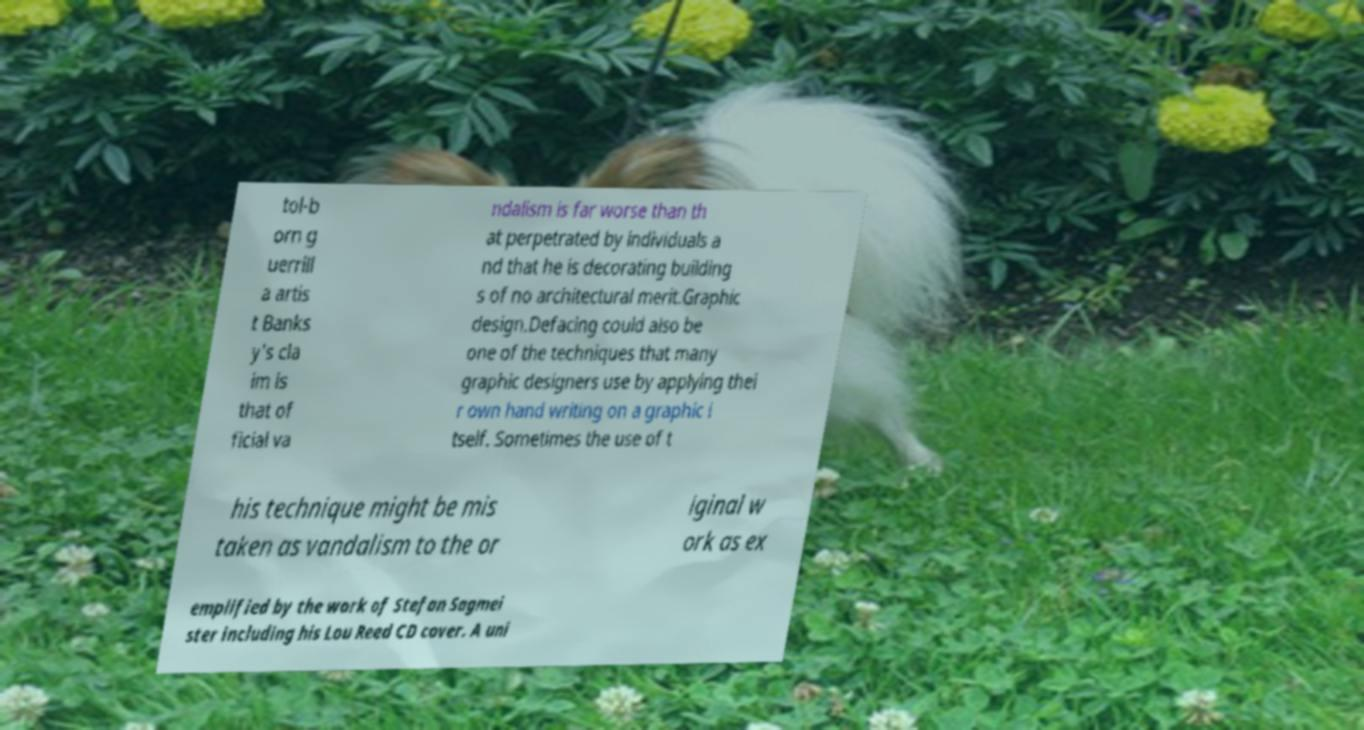I need the written content from this picture converted into text. Can you do that? tol-b orn g uerrill a artis t Banks y's cla im is that of ficial va ndalism is far worse than th at perpetrated by individuals a nd that he is decorating building s of no architectural merit.Graphic design.Defacing could also be one of the techniques that many graphic designers use by applying thei r own hand writing on a graphic i tself. Sometimes the use of t his technique might be mis taken as vandalism to the or iginal w ork as ex emplified by the work of Stefan Sagmei ster including his Lou Reed CD cover. A uni 